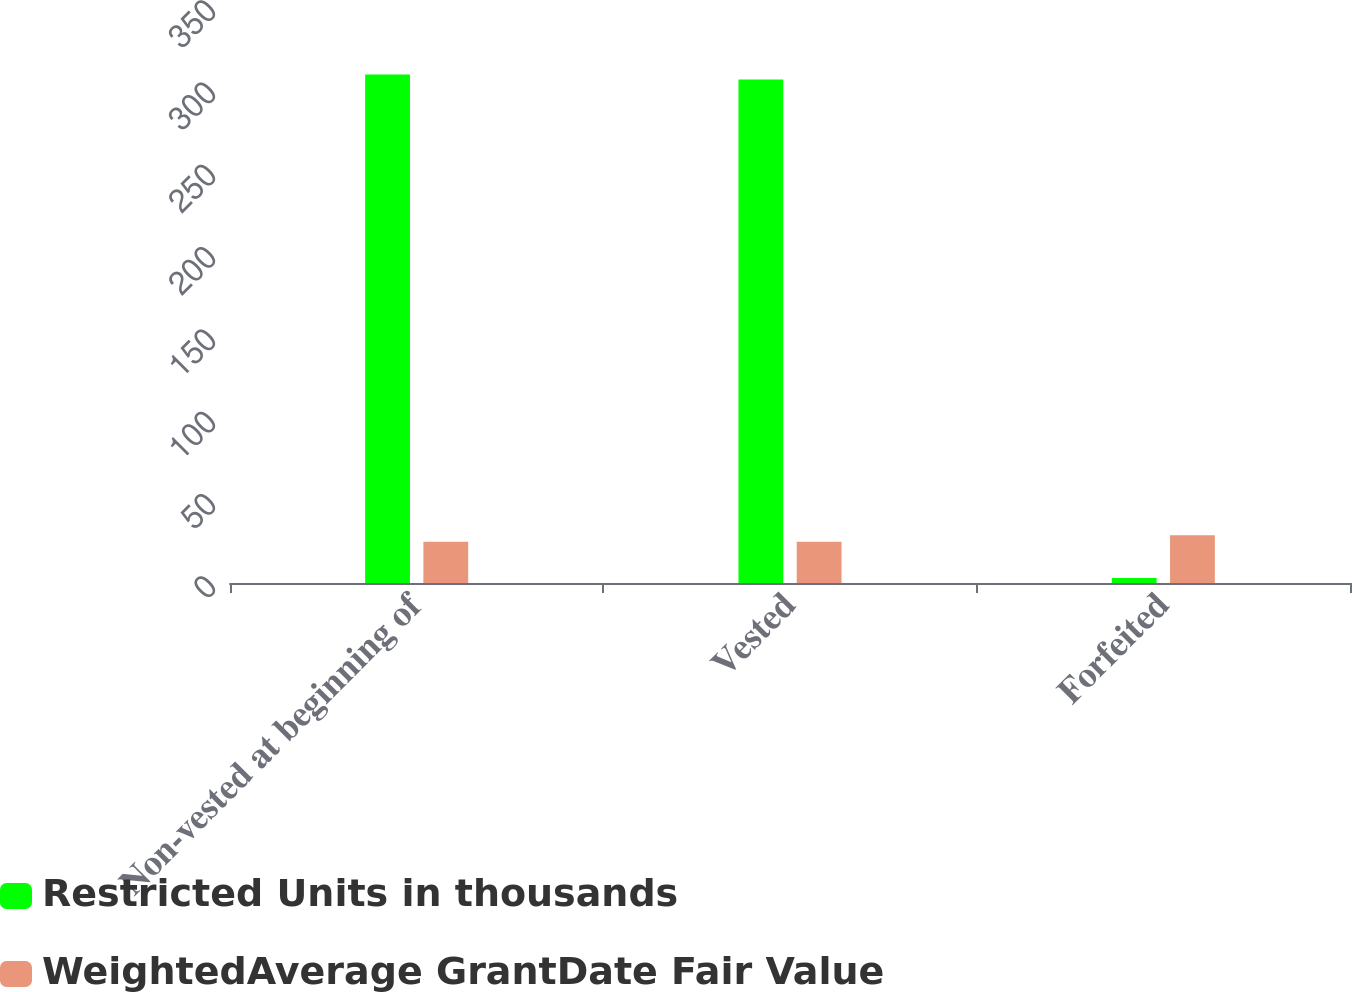Convert chart. <chart><loc_0><loc_0><loc_500><loc_500><stacked_bar_chart><ecel><fcel>Non-vested at beginning of<fcel>Vested<fcel>Forfeited<nl><fcel>Restricted Units in thousands<fcel>309<fcel>306<fcel>3<nl><fcel>WeightedAverage GrantDate Fair Value<fcel>25.08<fcel>25.04<fcel>28.99<nl></chart> 